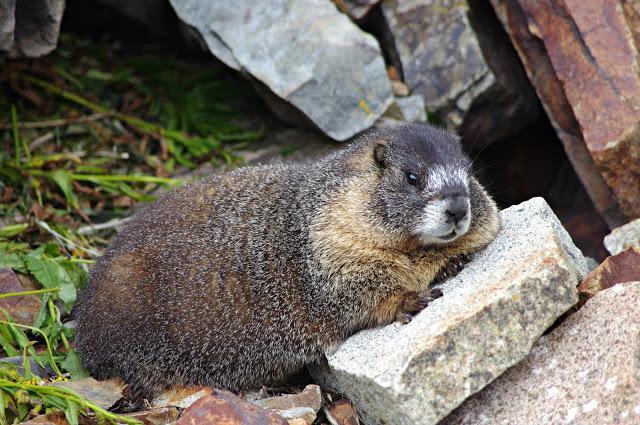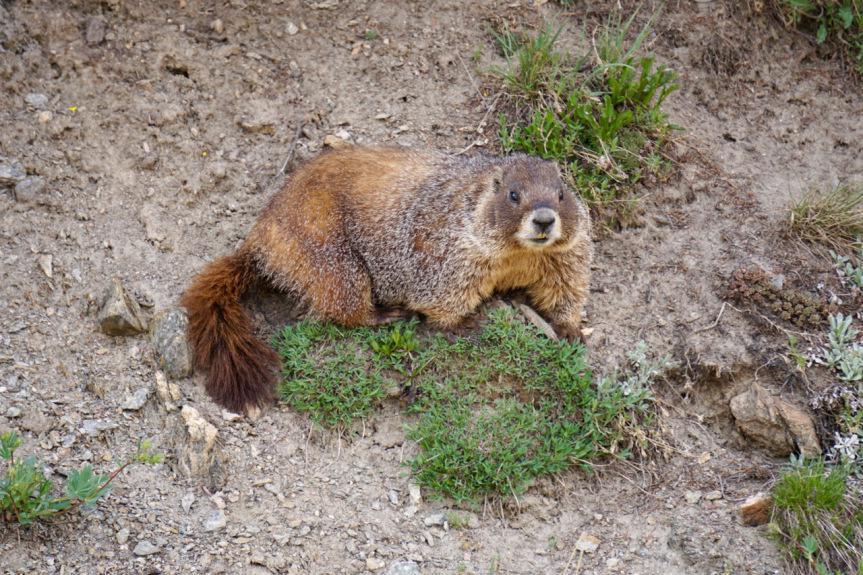The first image is the image on the left, the second image is the image on the right. Assess this claim about the two images: "The left image includes at least one marmot standing on its hind legs and clutching a piece of food near its mouth with both front paws.". Correct or not? Answer yes or no. No. The first image is the image on the left, the second image is the image on the right. Assess this claim about the two images: "The left and right image contains the same number of groundhogs with at least one eating.". Correct or not? Answer yes or no. No. 